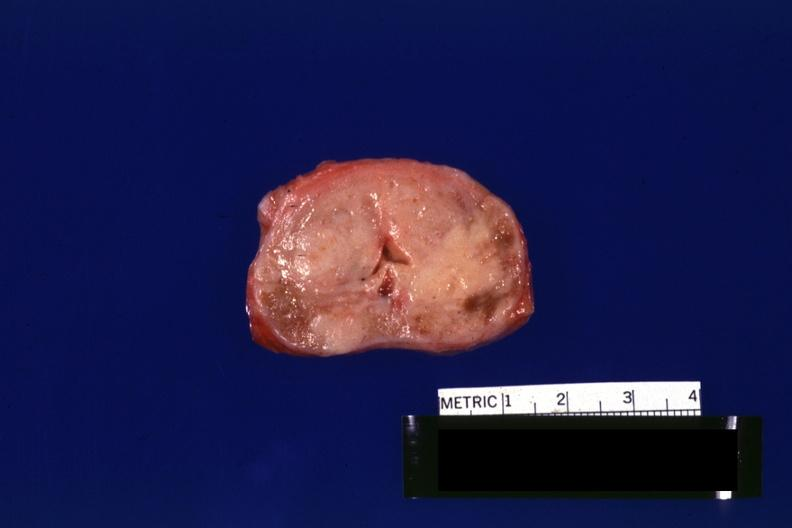what does this image show?
Answer the question using a single word or phrase. Excellent example to see neoplasm gland is not enlarged 